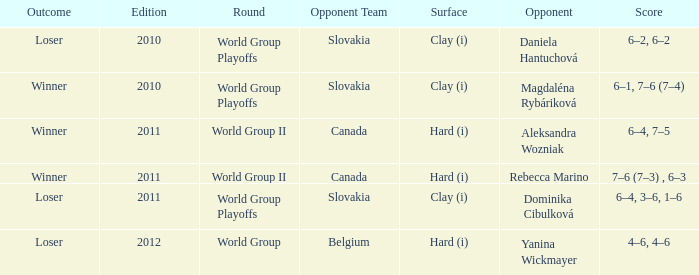What was the game edition when they played on the clay (i) surface and the outcome was a winner? 2010.0. 